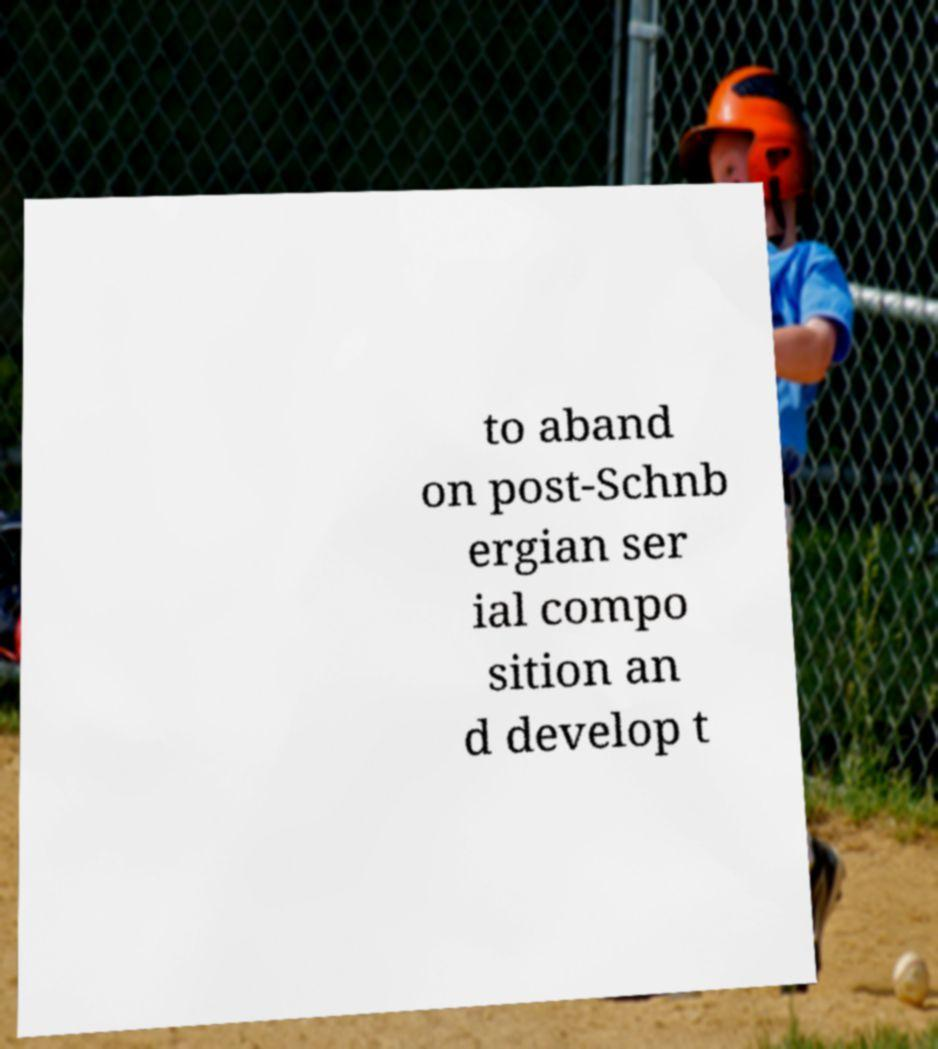There's text embedded in this image that I need extracted. Can you transcribe it verbatim? to aband on post-Schnb ergian ser ial compo sition an d develop t 